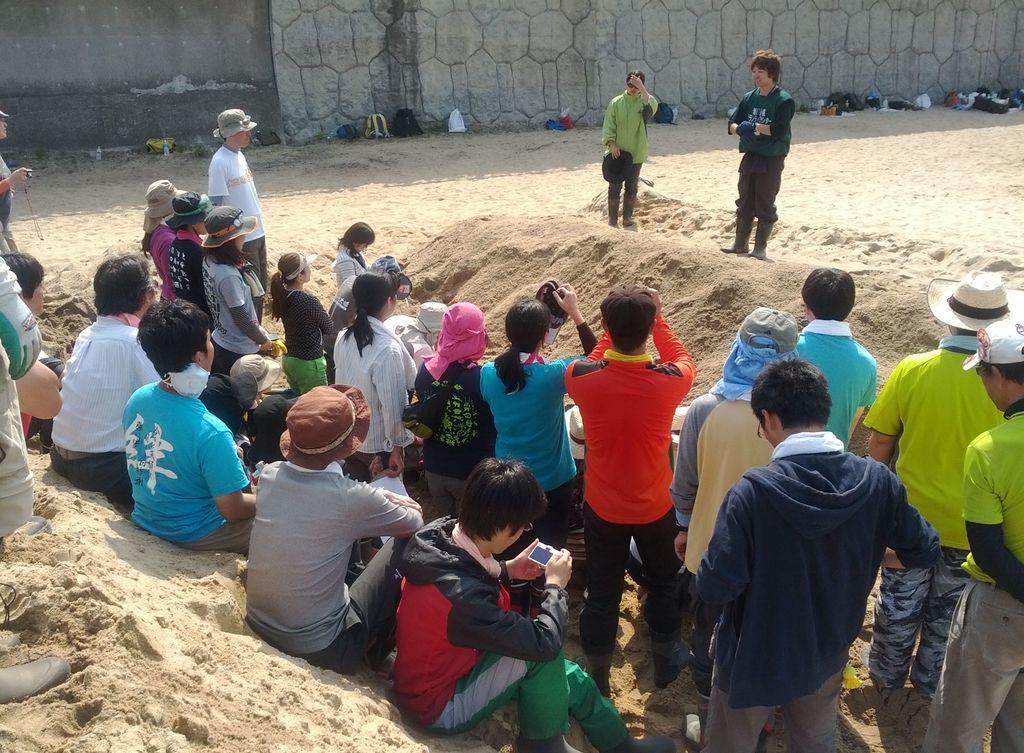Describe this image in one or two sentences. In this image in front there are people. There is sand. In the background of the image there is a wall. In front of the wall there are bags and a few other objects. 